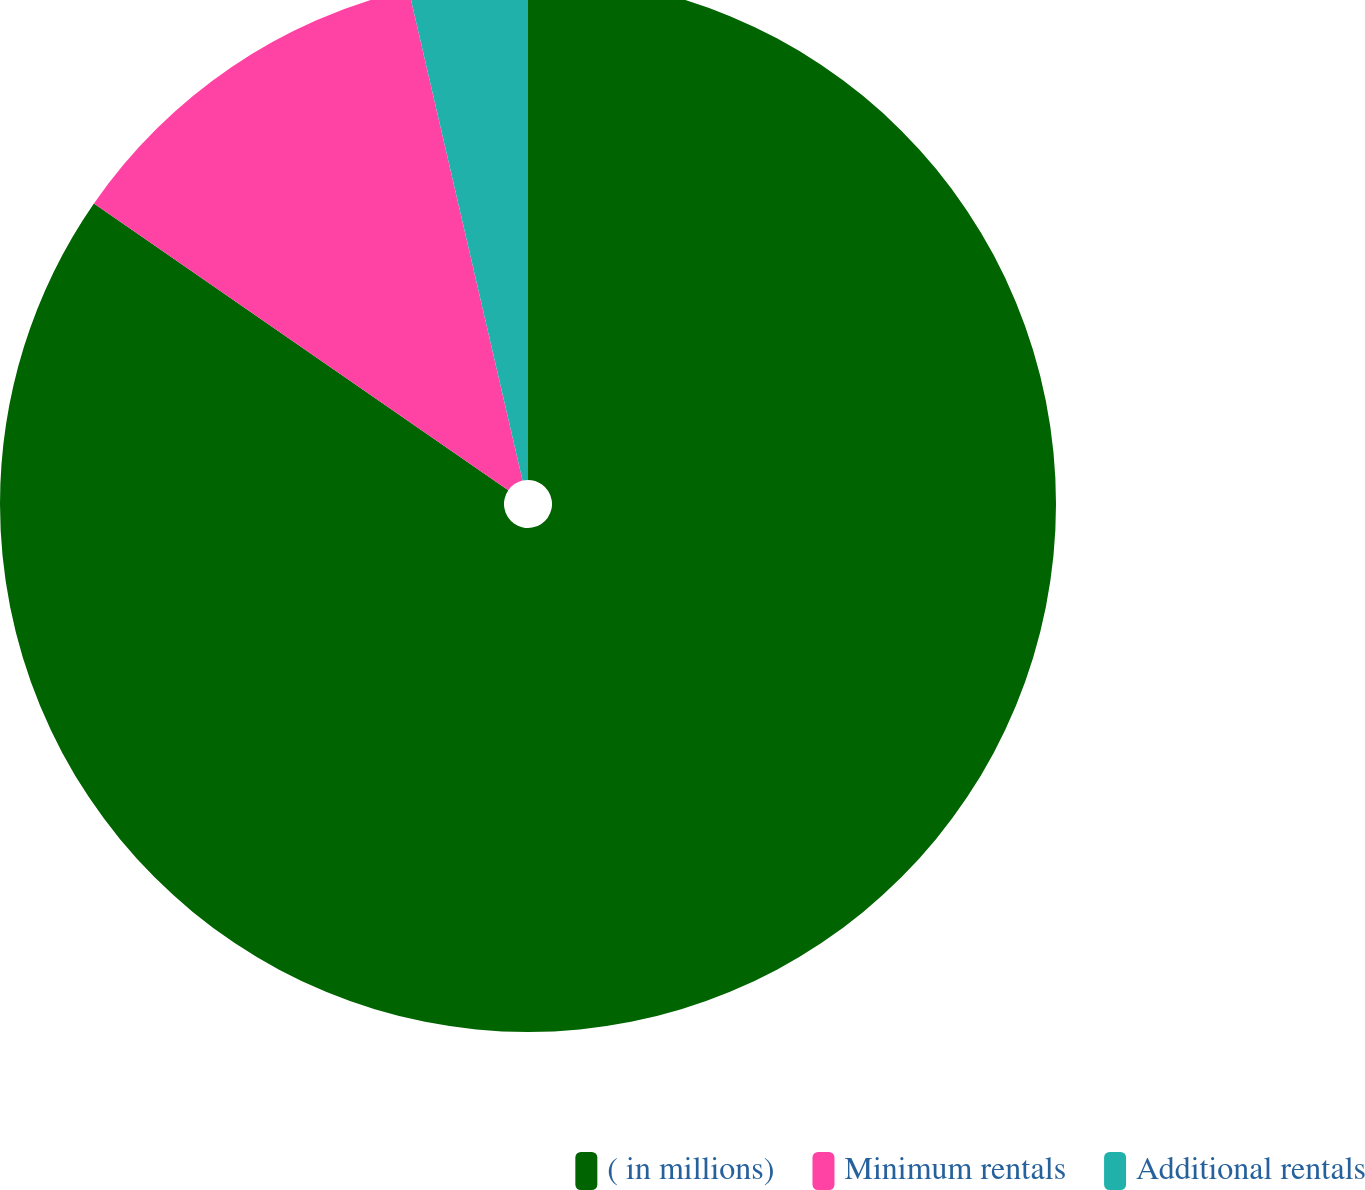Convert chart to OTSL. <chart><loc_0><loc_0><loc_500><loc_500><pie_chart><fcel>( in millions)<fcel>Minimum rentals<fcel>Additional rentals<nl><fcel>84.64%<fcel>11.73%<fcel>3.63%<nl></chart> 